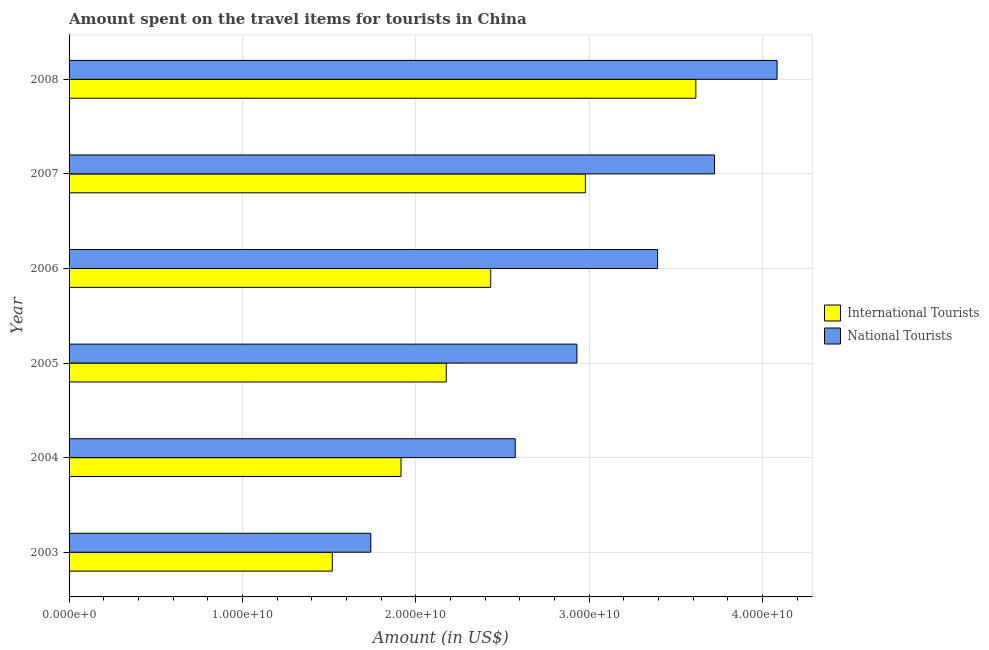How many groups of bars are there?
Provide a succinct answer. 6. Are the number of bars on each tick of the Y-axis equal?
Your answer should be very brief. Yes. How many bars are there on the 1st tick from the top?
Keep it short and to the point. 2. How many bars are there on the 2nd tick from the bottom?
Provide a succinct answer. 2. In how many cases, is the number of bars for a given year not equal to the number of legend labels?
Provide a succinct answer. 0. What is the amount spent on travel items of international tourists in 2005?
Provide a short and direct response. 2.18e+1. Across all years, what is the maximum amount spent on travel items of international tourists?
Your answer should be very brief. 3.62e+1. Across all years, what is the minimum amount spent on travel items of national tourists?
Provide a short and direct response. 1.74e+1. What is the total amount spent on travel items of national tourists in the graph?
Give a very brief answer. 1.84e+11. What is the difference between the amount spent on travel items of national tourists in 2004 and that in 2008?
Ensure brevity in your answer.  -1.51e+1. What is the difference between the amount spent on travel items of national tourists in 2005 and the amount spent on travel items of international tourists in 2007?
Make the answer very short. -4.90e+08. What is the average amount spent on travel items of national tourists per year?
Offer a very short reply. 3.07e+1. In the year 2005, what is the difference between the amount spent on travel items of national tourists and amount spent on travel items of international tourists?
Offer a terse response. 7.54e+09. What is the ratio of the amount spent on travel items of national tourists in 2004 to that in 2007?
Keep it short and to the point. 0.69. Is the amount spent on travel items of national tourists in 2004 less than that in 2005?
Your answer should be very brief. Yes. Is the difference between the amount spent on travel items of international tourists in 2003 and 2008 greater than the difference between the amount spent on travel items of national tourists in 2003 and 2008?
Offer a very short reply. Yes. What is the difference between the highest and the second highest amount spent on travel items of national tourists?
Offer a very short reply. 3.61e+09. What is the difference between the highest and the lowest amount spent on travel items of international tourists?
Your answer should be very brief. 2.10e+1. In how many years, is the amount spent on travel items of national tourists greater than the average amount spent on travel items of national tourists taken over all years?
Your answer should be very brief. 3. What does the 2nd bar from the top in 2003 represents?
Offer a terse response. International Tourists. What does the 2nd bar from the bottom in 2005 represents?
Ensure brevity in your answer.  National Tourists. How many bars are there?
Provide a short and direct response. 12. What is the difference between two consecutive major ticks on the X-axis?
Provide a succinct answer. 1.00e+1. Where does the legend appear in the graph?
Make the answer very short. Center right. What is the title of the graph?
Offer a terse response. Amount spent on the travel items for tourists in China. Does "Investments" appear as one of the legend labels in the graph?
Your answer should be very brief. No. What is the label or title of the X-axis?
Your answer should be compact. Amount (in US$). What is the Amount (in US$) of International Tourists in 2003?
Keep it short and to the point. 1.52e+1. What is the Amount (in US$) of National Tourists in 2003?
Give a very brief answer. 1.74e+1. What is the Amount (in US$) of International Tourists in 2004?
Provide a short and direct response. 1.91e+1. What is the Amount (in US$) of National Tourists in 2004?
Keep it short and to the point. 2.57e+1. What is the Amount (in US$) of International Tourists in 2005?
Your answer should be very brief. 2.18e+1. What is the Amount (in US$) of National Tourists in 2005?
Your answer should be compact. 2.93e+1. What is the Amount (in US$) in International Tourists in 2006?
Ensure brevity in your answer.  2.43e+1. What is the Amount (in US$) in National Tourists in 2006?
Keep it short and to the point. 3.39e+1. What is the Amount (in US$) in International Tourists in 2007?
Provide a succinct answer. 2.98e+1. What is the Amount (in US$) of National Tourists in 2007?
Keep it short and to the point. 3.72e+1. What is the Amount (in US$) in International Tourists in 2008?
Ensure brevity in your answer.  3.62e+1. What is the Amount (in US$) in National Tourists in 2008?
Give a very brief answer. 4.08e+1. Across all years, what is the maximum Amount (in US$) in International Tourists?
Give a very brief answer. 3.62e+1. Across all years, what is the maximum Amount (in US$) of National Tourists?
Provide a succinct answer. 4.08e+1. Across all years, what is the minimum Amount (in US$) of International Tourists?
Make the answer very short. 1.52e+1. Across all years, what is the minimum Amount (in US$) of National Tourists?
Keep it short and to the point. 1.74e+1. What is the total Amount (in US$) of International Tourists in the graph?
Your response must be concise. 1.46e+11. What is the total Amount (in US$) of National Tourists in the graph?
Provide a short and direct response. 1.84e+11. What is the difference between the Amount (in US$) of International Tourists in 2003 and that in 2004?
Make the answer very short. -3.96e+09. What is the difference between the Amount (in US$) of National Tourists in 2003 and that in 2004?
Provide a short and direct response. -8.33e+09. What is the difference between the Amount (in US$) of International Tourists in 2003 and that in 2005?
Give a very brief answer. -6.57e+09. What is the difference between the Amount (in US$) of National Tourists in 2003 and that in 2005?
Provide a short and direct response. -1.19e+1. What is the difference between the Amount (in US$) of International Tourists in 2003 and that in 2006?
Keep it short and to the point. -9.14e+09. What is the difference between the Amount (in US$) in National Tourists in 2003 and that in 2006?
Keep it short and to the point. -1.65e+1. What is the difference between the Amount (in US$) of International Tourists in 2003 and that in 2007?
Your response must be concise. -1.46e+1. What is the difference between the Amount (in US$) of National Tourists in 2003 and that in 2007?
Your response must be concise. -1.98e+1. What is the difference between the Amount (in US$) in International Tourists in 2003 and that in 2008?
Your response must be concise. -2.10e+1. What is the difference between the Amount (in US$) of National Tourists in 2003 and that in 2008?
Ensure brevity in your answer.  -2.34e+1. What is the difference between the Amount (in US$) of International Tourists in 2004 and that in 2005?
Offer a very short reply. -2.61e+09. What is the difference between the Amount (in US$) in National Tourists in 2004 and that in 2005?
Ensure brevity in your answer.  -3.56e+09. What is the difference between the Amount (in US$) of International Tourists in 2004 and that in 2006?
Provide a succinct answer. -5.17e+09. What is the difference between the Amount (in US$) of National Tourists in 2004 and that in 2006?
Offer a terse response. -8.21e+09. What is the difference between the Amount (in US$) of International Tourists in 2004 and that in 2007?
Give a very brief answer. -1.06e+1. What is the difference between the Amount (in US$) in National Tourists in 2004 and that in 2007?
Offer a terse response. -1.15e+1. What is the difference between the Amount (in US$) in International Tourists in 2004 and that in 2008?
Provide a succinct answer. -1.70e+1. What is the difference between the Amount (in US$) of National Tourists in 2004 and that in 2008?
Offer a very short reply. -1.51e+1. What is the difference between the Amount (in US$) in International Tourists in 2005 and that in 2006?
Ensure brevity in your answer.  -2.56e+09. What is the difference between the Amount (in US$) of National Tourists in 2005 and that in 2006?
Offer a terse response. -4.65e+09. What is the difference between the Amount (in US$) in International Tourists in 2005 and that in 2007?
Ensure brevity in your answer.  -8.03e+09. What is the difference between the Amount (in US$) in National Tourists in 2005 and that in 2007?
Provide a short and direct response. -7.94e+09. What is the difference between the Amount (in US$) in International Tourists in 2005 and that in 2008?
Offer a terse response. -1.44e+1. What is the difference between the Amount (in US$) in National Tourists in 2005 and that in 2008?
Give a very brief answer. -1.15e+1. What is the difference between the Amount (in US$) in International Tourists in 2006 and that in 2007?
Provide a succinct answer. -5.46e+09. What is the difference between the Amount (in US$) in National Tourists in 2006 and that in 2007?
Give a very brief answer. -3.28e+09. What is the difference between the Amount (in US$) in International Tourists in 2006 and that in 2008?
Provide a succinct answer. -1.18e+1. What is the difference between the Amount (in US$) of National Tourists in 2006 and that in 2008?
Keep it short and to the point. -6.89e+09. What is the difference between the Amount (in US$) of International Tourists in 2007 and that in 2008?
Your answer should be very brief. -6.37e+09. What is the difference between the Amount (in US$) in National Tourists in 2007 and that in 2008?
Provide a short and direct response. -3.61e+09. What is the difference between the Amount (in US$) in International Tourists in 2003 and the Amount (in US$) in National Tourists in 2004?
Offer a very short reply. -1.06e+1. What is the difference between the Amount (in US$) of International Tourists in 2003 and the Amount (in US$) of National Tourists in 2005?
Offer a terse response. -1.41e+1. What is the difference between the Amount (in US$) in International Tourists in 2003 and the Amount (in US$) in National Tourists in 2006?
Offer a terse response. -1.88e+1. What is the difference between the Amount (in US$) in International Tourists in 2003 and the Amount (in US$) in National Tourists in 2007?
Make the answer very short. -2.20e+1. What is the difference between the Amount (in US$) in International Tourists in 2003 and the Amount (in US$) in National Tourists in 2008?
Offer a terse response. -2.57e+1. What is the difference between the Amount (in US$) in International Tourists in 2004 and the Amount (in US$) in National Tourists in 2005?
Your answer should be very brief. -1.01e+1. What is the difference between the Amount (in US$) of International Tourists in 2004 and the Amount (in US$) of National Tourists in 2006?
Ensure brevity in your answer.  -1.48e+1. What is the difference between the Amount (in US$) of International Tourists in 2004 and the Amount (in US$) of National Tourists in 2007?
Give a very brief answer. -1.81e+1. What is the difference between the Amount (in US$) in International Tourists in 2004 and the Amount (in US$) in National Tourists in 2008?
Your answer should be compact. -2.17e+1. What is the difference between the Amount (in US$) in International Tourists in 2005 and the Amount (in US$) in National Tourists in 2006?
Ensure brevity in your answer.  -1.22e+1. What is the difference between the Amount (in US$) of International Tourists in 2005 and the Amount (in US$) of National Tourists in 2007?
Keep it short and to the point. -1.55e+1. What is the difference between the Amount (in US$) in International Tourists in 2005 and the Amount (in US$) in National Tourists in 2008?
Offer a terse response. -1.91e+1. What is the difference between the Amount (in US$) of International Tourists in 2006 and the Amount (in US$) of National Tourists in 2007?
Your answer should be compact. -1.29e+1. What is the difference between the Amount (in US$) in International Tourists in 2006 and the Amount (in US$) in National Tourists in 2008?
Your answer should be very brief. -1.65e+1. What is the difference between the Amount (in US$) in International Tourists in 2007 and the Amount (in US$) in National Tourists in 2008?
Give a very brief answer. -1.11e+1. What is the average Amount (in US$) of International Tourists per year?
Keep it short and to the point. 2.44e+1. What is the average Amount (in US$) of National Tourists per year?
Your answer should be compact. 3.07e+1. In the year 2003, what is the difference between the Amount (in US$) in International Tourists and Amount (in US$) in National Tourists?
Provide a succinct answer. -2.22e+09. In the year 2004, what is the difference between the Amount (in US$) of International Tourists and Amount (in US$) of National Tourists?
Your answer should be very brief. -6.59e+09. In the year 2005, what is the difference between the Amount (in US$) of International Tourists and Amount (in US$) of National Tourists?
Provide a succinct answer. -7.54e+09. In the year 2006, what is the difference between the Amount (in US$) of International Tourists and Amount (in US$) of National Tourists?
Make the answer very short. -9.63e+09. In the year 2007, what is the difference between the Amount (in US$) in International Tourists and Amount (in US$) in National Tourists?
Offer a very short reply. -7.45e+09. In the year 2008, what is the difference between the Amount (in US$) in International Tourists and Amount (in US$) in National Tourists?
Make the answer very short. -4.69e+09. What is the ratio of the Amount (in US$) in International Tourists in 2003 to that in 2004?
Make the answer very short. 0.79. What is the ratio of the Amount (in US$) in National Tourists in 2003 to that in 2004?
Offer a terse response. 0.68. What is the ratio of the Amount (in US$) in International Tourists in 2003 to that in 2005?
Your answer should be very brief. 0.7. What is the ratio of the Amount (in US$) of National Tourists in 2003 to that in 2005?
Make the answer very short. 0.59. What is the ratio of the Amount (in US$) of International Tourists in 2003 to that in 2006?
Keep it short and to the point. 0.62. What is the ratio of the Amount (in US$) in National Tourists in 2003 to that in 2006?
Offer a terse response. 0.51. What is the ratio of the Amount (in US$) in International Tourists in 2003 to that in 2007?
Ensure brevity in your answer.  0.51. What is the ratio of the Amount (in US$) in National Tourists in 2003 to that in 2007?
Give a very brief answer. 0.47. What is the ratio of the Amount (in US$) in International Tourists in 2003 to that in 2008?
Make the answer very short. 0.42. What is the ratio of the Amount (in US$) in National Tourists in 2003 to that in 2008?
Your answer should be compact. 0.43. What is the ratio of the Amount (in US$) of International Tourists in 2004 to that in 2005?
Provide a short and direct response. 0.88. What is the ratio of the Amount (in US$) of National Tourists in 2004 to that in 2005?
Give a very brief answer. 0.88. What is the ratio of the Amount (in US$) in International Tourists in 2004 to that in 2006?
Your answer should be very brief. 0.79. What is the ratio of the Amount (in US$) in National Tourists in 2004 to that in 2006?
Give a very brief answer. 0.76. What is the ratio of the Amount (in US$) in International Tourists in 2004 to that in 2007?
Ensure brevity in your answer.  0.64. What is the ratio of the Amount (in US$) of National Tourists in 2004 to that in 2007?
Offer a terse response. 0.69. What is the ratio of the Amount (in US$) of International Tourists in 2004 to that in 2008?
Offer a very short reply. 0.53. What is the ratio of the Amount (in US$) of National Tourists in 2004 to that in 2008?
Your answer should be very brief. 0.63. What is the ratio of the Amount (in US$) of International Tourists in 2005 to that in 2006?
Your response must be concise. 0.89. What is the ratio of the Amount (in US$) of National Tourists in 2005 to that in 2006?
Ensure brevity in your answer.  0.86. What is the ratio of the Amount (in US$) of International Tourists in 2005 to that in 2007?
Keep it short and to the point. 0.73. What is the ratio of the Amount (in US$) of National Tourists in 2005 to that in 2007?
Your response must be concise. 0.79. What is the ratio of the Amount (in US$) in International Tourists in 2005 to that in 2008?
Your answer should be compact. 0.6. What is the ratio of the Amount (in US$) in National Tourists in 2005 to that in 2008?
Ensure brevity in your answer.  0.72. What is the ratio of the Amount (in US$) of International Tourists in 2006 to that in 2007?
Give a very brief answer. 0.82. What is the ratio of the Amount (in US$) of National Tourists in 2006 to that in 2007?
Offer a very short reply. 0.91. What is the ratio of the Amount (in US$) of International Tourists in 2006 to that in 2008?
Make the answer very short. 0.67. What is the ratio of the Amount (in US$) of National Tourists in 2006 to that in 2008?
Offer a very short reply. 0.83. What is the ratio of the Amount (in US$) of International Tourists in 2007 to that in 2008?
Provide a short and direct response. 0.82. What is the ratio of the Amount (in US$) in National Tourists in 2007 to that in 2008?
Offer a terse response. 0.91. What is the difference between the highest and the second highest Amount (in US$) of International Tourists?
Provide a short and direct response. 6.37e+09. What is the difference between the highest and the second highest Amount (in US$) of National Tourists?
Your answer should be very brief. 3.61e+09. What is the difference between the highest and the lowest Amount (in US$) of International Tourists?
Your answer should be compact. 2.10e+1. What is the difference between the highest and the lowest Amount (in US$) of National Tourists?
Offer a terse response. 2.34e+1. 